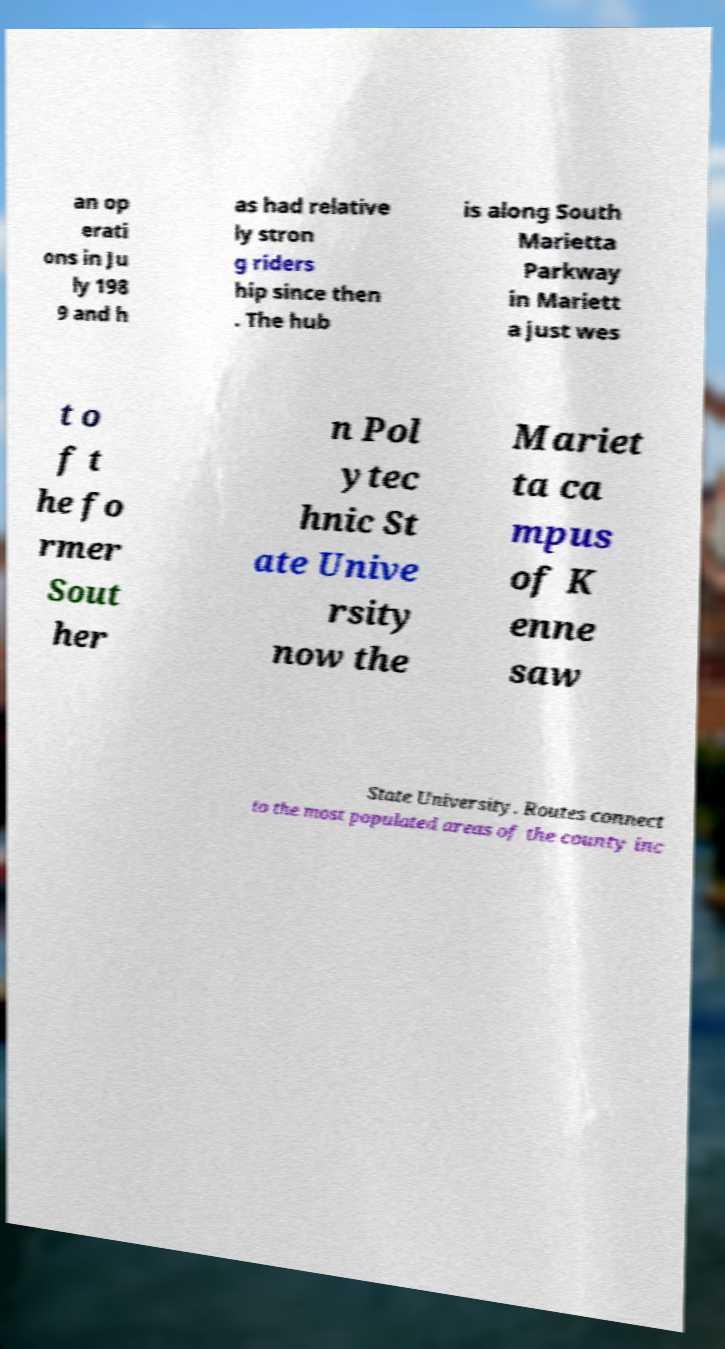I need the written content from this picture converted into text. Can you do that? an op erati ons in Ju ly 198 9 and h as had relative ly stron g riders hip since then . The hub is along South Marietta Parkway in Mariett a just wes t o f t he fo rmer Sout her n Pol ytec hnic St ate Unive rsity now the Mariet ta ca mpus of K enne saw State University. Routes connect to the most populated areas of the county inc 